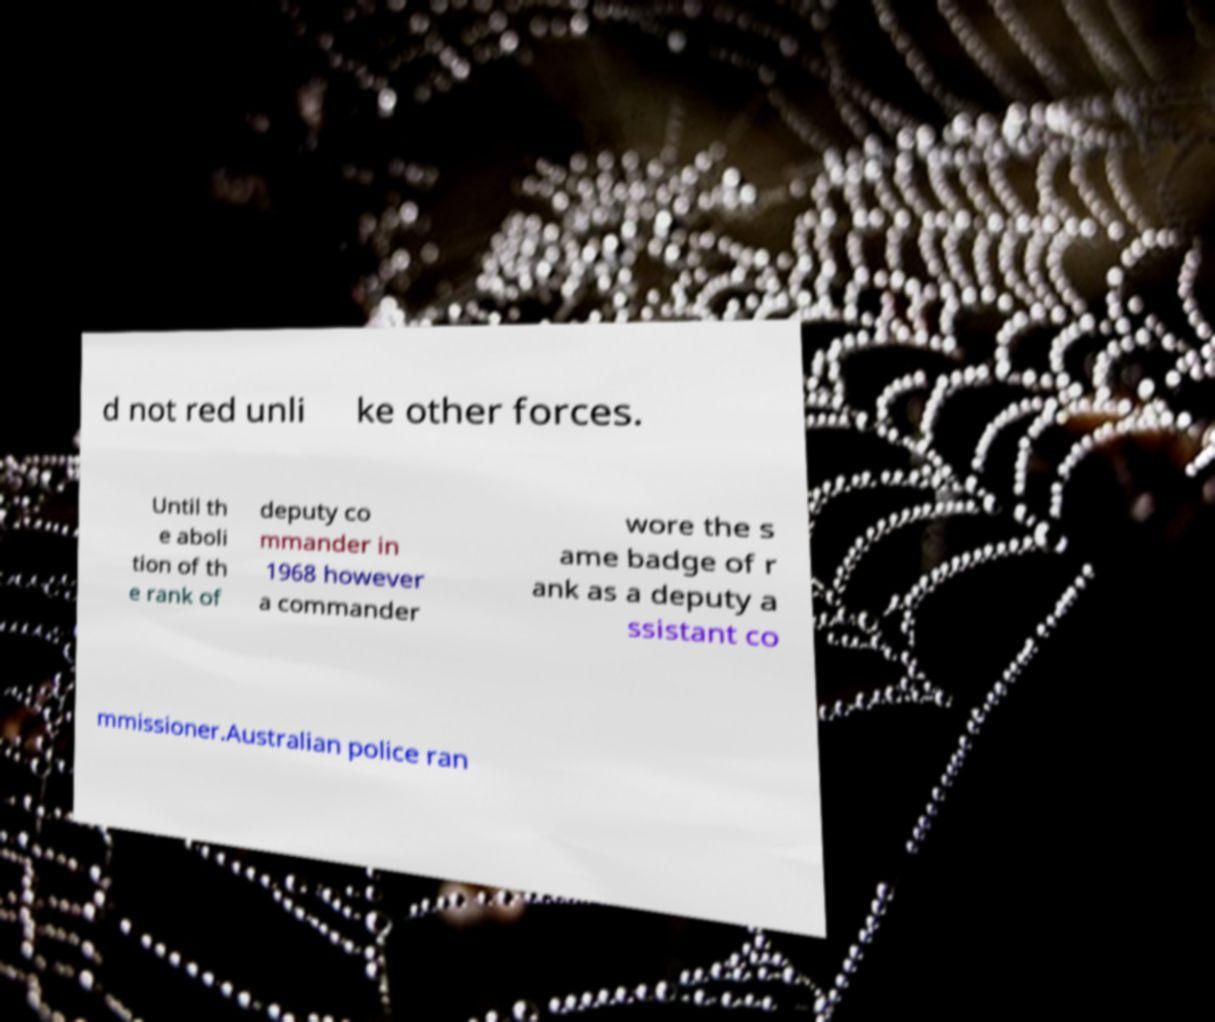Please read and relay the text visible in this image. What does it say? d not red unli ke other forces. Until th e aboli tion of th e rank of deputy co mmander in 1968 however a commander wore the s ame badge of r ank as a deputy a ssistant co mmissioner.Australian police ran 